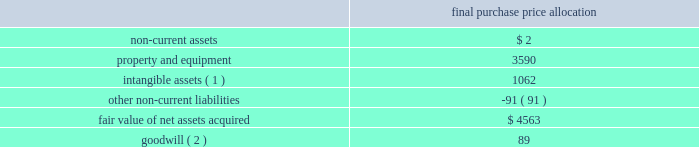American tower corporation and subsidiaries notes to consolidated financial statements the allocation of the purchase price was finalized during the year ended december 31 , 2012 .
The table summarizes the allocation of the aggregate purchase consideration paid and the amounts of assets acquired and liabilities assumed based upon their estimated fair value at the date of acquisition ( in thousands ) : purchase price allocation .
( 1 ) consists of customer-related intangibles of approximately $ 0.4 million and network location intangibles of approximately $ 0.7 million .
The customer-related intangibles and network location intangibles are being amortized on a straight-line basis over periods of up to 20 years .
( 2 ) the company expects that the goodwill recorded will be deductible for tax purposes .
The goodwill was allocated to the company 2019s international rental and management segment .
Colombia 2014colombia movil acquisition 2014on july 17 , 2011 , the company entered into a definitive agreement with colombia movil s.a .
E.s.p .
( 201ccolombia movil 201d ) , whereby atc sitios infraco , s.a.s. , a colombian subsidiary of the company ( 201catc infraco 201d ) , would purchase up to 2126 communications sites from colombia movil for an aggregate purchase price of approximately $ 182.0 million .
From december 21 , 2011 through the year ended december 31 , 2012 , atc infraco completed the purchase of 1526 communications sites for an aggregate purchase price of $ 136.2 million ( including contingent consideration of $ 17.3 million ) , subject to post-closing adjustments .
Through a subsidiary , millicom international cellular s.a .
( 201cmillicom 201d ) exercised its option to acquire an indirect , substantial non-controlling interest in atc infraco .
Under the terms of the agreement , the company is required to make additional payments upon the conversion of certain barter agreements with other wireless carriers to cash paying lease agreements .
Based on the company 2019s current estimates , the value of potential contingent consideration payments required to be made under the amended agreement is expected to be between zero and $ 32.8 million and is estimated to be $ 17.3 million using a probability weighted average of the expected outcomes at december 31 , 2012 .
During the year ended december 31 , 2012 , the company recorded a reduction in fair value of $ 1.2 million , which is included in other operating expenses in the consolidated statements of operations. .
What was the cost per tower in the colombia movil acquisition? 
Computations: ((182.0 * 1000000) / 2126)
Answer: 85606.77328. 